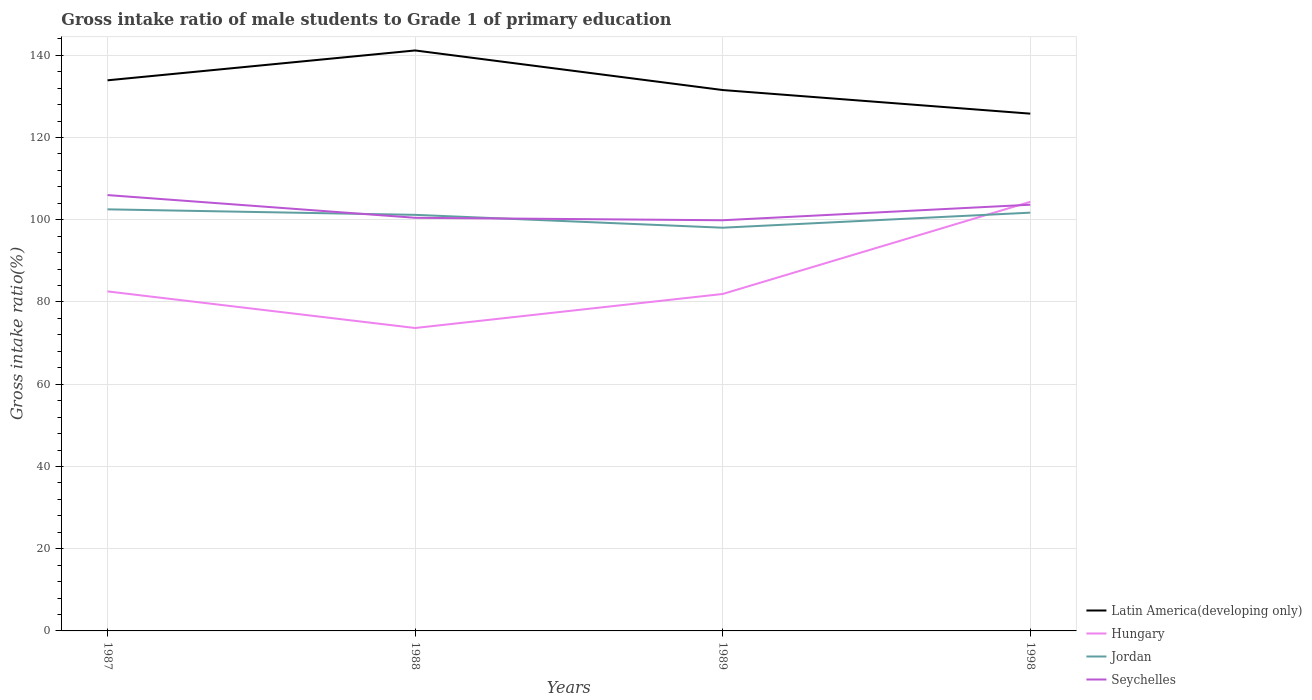How many different coloured lines are there?
Offer a terse response. 4. Does the line corresponding to Seychelles intersect with the line corresponding to Hungary?
Give a very brief answer. Yes. Across all years, what is the maximum gross intake ratio in Seychelles?
Your answer should be very brief. 99.88. In which year was the gross intake ratio in Seychelles maximum?
Your answer should be very brief. 1989. What is the total gross intake ratio in Jordan in the graph?
Offer a terse response. 4.46. What is the difference between the highest and the second highest gross intake ratio in Jordan?
Make the answer very short. 4.46. Is the gross intake ratio in Hungary strictly greater than the gross intake ratio in Jordan over the years?
Ensure brevity in your answer.  No. How many lines are there?
Keep it short and to the point. 4. Are the values on the major ticks of Y-axis written in scientific E-notation?
Give a very brief answer. No. Does the graph contain grids?
Your response must be concise. Yes. Where does the legend appear in the graph?
Give a very brief answer. Bottom right. How many legend labels are there?
Your answer should be compact. 4. How are the legend labels stacked?
Offer a terse response. Vertical. What is the title of the graph?
Offer a very short reply. Gross intake ratio of male students to Grade 1 of primary education. Does "Honduras" appear as one of the legend labels in the graph?
Make the answer very short. No. What is the label or title of the X-axis?
Provide a short and direct response. Years. What is the label or title of the Y-axis?
Ensure brevity in your answer.  Gross intake ratio(%). What is the Gross intake ratio(%) of Latin America(developing only) in 1987?
Your response must be concise. 133.92. What is the Gross intake ratio(%) in Hungary in 1987?
Provide a short and direct response. 82.57. What is the Gross intake ratio(%) of Jordan in 1987?
Ensure brevity in your answer.  102.53. What is the Gross intake ratio(%) in Seychelles in 1987?
Ensure brevity in your answer.  106. What is the Gross intake ratio(%) in Latin America(developing only) in 1988?
Provide a succinct answer. 141.18. What is the Gross intake ratio(%) of Hungary in 1988?
Give a very brief answer. 73.68. What is the Gross intake ratio(%) in Jordan in 1988?
Offer a terse response. 101.2. What is the Gross intake ratio(%) in Seychelles in 1988?
Ensure brevity in your answer.  100.48. What is the Gross intake ratio(%) in Latin America(developing only) in 1989?
Ensure brevity in your answer.  131.55. What is the Gross intake ratio(%) in Hungary in 1989?
Offer a very short reply. 81.95. What is the Gross intake ratio(%) in Jordan in 1989?
Provide a succinct answer. 98.07. What is the Gross intake ratio(%) in Seychelles in 1989?
Ensure brevity in your answer.  99.88. What is the Gross intake ratio(%) of Latin America(developing only) in 1998?
Provide a short and direct response. 125.81. What is the Gross intake ratio(%) in Hungary in 1998?
Keep it short and to the point. 104.37. What is the Gross intake ratio(%) of Jordan in 1998?
Your response must be concise. 101.73. What is the Gross intake ratio(%) in Seychelles in 1998?
Give a very brief answer. 103.66. Across all years, what is the maximum Gross intake ratio(%) in Latin America(developing only)?
Offer a very short reply. 141.18. Across all years, what is the maximum Gross intake ratio(%) in Hungary?
Your response must be concise. 104.37. Across all years, what is the maximum Gross intake ratio(%) of Jordan?
Your answer should be compact. 102.53. Across all years, what is the maximum Gross intake ratio(%) in Seychelles?
Provide a succinct answer. 106. Across all years, what is the minimum Gross intake ratio(%) in Latin America(developing only)?
Provide a succinct answer. 125.81. Across all years, what is the minimum Gross intake ratio(%) of Hungary?
Offer a very short reply. 73.68. Across all years, what is the minimum Gross intake ratio(%) in Jordan?
Offer a very short reply. 98.07. Across all years, what is the minimum Gross intake ratio(%) in Seychelles?
Your response must be concise. 99.88. What is the total Gross intake ratio(%) in Latin America(developing only) in the graph?
Make the answer very short. 532.46. What is the total Gross intake ratio(%) of Hungary in the graph?
Your response must be concise. 342.57. What is the total Gross intake ratio(%) in Jordan in the graph?
Your answer should be very brief. 403.53. What is the total Gross intake ratio(%) of Seychelles in the graph?
Offer a very short reply. 410.03. What is the difference between the Gross intake ratio(%) in Latin America(developing only) in 1987 and that in 1988?
Your response must be concise. -7.26. What is the difference between the Gross intake ratio(%) of Hungary in 1987 and that in 1988?
Provide a short and direct response. 8.9. What is the difference between the Gross intake ratio(%) of Jordan in 1987 and that in 1988?
Provide a succinct answer. 1.34. What is the difference between the Gross intake ratio(%) in Seychelles in 1987 and that in 1988?
Provide a succinct answer. 5.52. What is the difference between the Gross intake ratio(%) of Latin America(developing only) in 1987 and that in 1989?
Offer a very short reply. 2.37. What is the difference between the Gross intake ratio(%) of Hungary in 1987 and that in 1989?
Provide a succinct answer. 0.62. What is the difference between the Gross intake ratio(%) of Jordan in 1987 and that in 1989?
Your answer should be compact. 4.46. What is the difference between the Gross intake ratio(%) of Seychelles in 1987 and that in 1989?
Your answer should be very brief. 6.12. What is the difference between the Gross intake ratio(%) of Latin America(developing only) in 1987 and that in 1998?
Ensure brevity in your answer.  8.11. What is the difference between the Gross intake ratio(%) of Hungary in 1987 and that in 1998?
Keep it short and to the point. -21.8. What is the difference between the Gross intake ratio(%) of Jordan in 1987 and that in 1998?
Give a very brief answer. 0.8. What is the difference between the Gross intake ratio(%) of Seychelles in 1987 and that in 1998?
Make the answer very short. 2.34. What is the difference between the Gross intake ratio(%) in Latin America(developing only) in 1988 and that in 1989?
Your response must be concise. 9.63. What is the difference between the Gross intake ratio(%) in Hungary in 1988 and that in 1989?
Offer a terse response. -8.27. What is the difference between the Gross intake ratio(%) in Jordan in 1988 and that in 1989?
Offer a terse response. 3.13. What is the difference between the Gross intake ratio(%) in Seychelles in 1988 and that in 1989?
Give a very brief answer. 0.6. What is the difference between the Gross intake ratio(%) of Latin America(developing only) in 1988 and that in 1998?
Provide a short and direct response. 15.37. What is the difference between the Gross intake ratio(%) in Hungary in 1988 and that in 1998?
Your response must be concise. -30.69. What is the difference between the Gross intake ratio(%) of Jordan in 1988 and that in 1998?
Provide a succinct answer. -0.53. What is the difference between the Gross intake ratio(%) of Seychelles in 1988 and that in 1998?
Offer a terse response. -3.18. What is the difference between the Gross intake ratio(%) in Latin America(developing only) in 1989 and that in 1998?
Give a very brief answer. 5.74. What is the difference between the Gross intake ratio(%) of Hungary in 1989 and that in 1998?
Your answer should be very brief. -22.42. What is the difference between the Gross intake ratio(%) in Jordan in 1989 and that in 1998?
Offer a terse response. -3.66. What is the difference between the Gross intake ratio(%) in Seychelles in 1989 and that in 1998?
Your answer should be compact. -3.78. What is the difference between the Gross intake ratio(%) of Latin America(developing only) in 1987 and the Gross intake ratio(%) of Hungary in 1988?
Your answer should be very brief. 60.24. What is the difference between the Gross intake ratio(%) in Latin America(developing only) in 1987 and the Gross intake ratio(%) in Jordan in 1988?
Make the answer very short. 32.72. What is the difference between the Gross intake ratio(%) of Latin America(developing only) in 1987 and the Gross intake ratio(%) of Seychelles in 1988?
Your answer should be very brief. 33.44. What is the difference between the Gross intake ratio(%) of Hungary in 1987 and the Gross intake ratio(%) of Jordan in 1988?
Give a very brief answer. -18.62. What is the difference between the Gross intake ratio(%) in Hungary in 1987 and the Gross intake ratio(%) in Seychelles in 1988?
Ensure brevity in your answer.  -17.91. What is the difference between the Gross intake ratio(%) in Jordan in 1987 and the Gross intake ratio(%) in Seychelles in 1988?
Offer a very short reply. 2.05. What is the difference between the Gross intake ratio(%) in Latin America(developing only) in 1987 and the Gross intake ratio(%) in Hungary in 1989?
Make the answer very short. 51.97. What is the difference between the Gross intake ratio(%) of Latin America(developing only) in 1987 and the Gross intake ratio(%) of Jordan in 1989?
Provide a short and direct response. 35.85. What is the difference between the Gross intake ratio(%) in Latin America(developing only) in 1987 and the Gross intake ratio(%) in Seychelles in 1989?
Provide a succinct answer. 34.03. What is the difference between the Gross intake ratio(%) in Hungary in 1987 and the Gross intake ratio(%) in Jordan in 1989?
Your response must be concise. -15.5. What is the difference between the Gross intake ratio(%) of Hungary in 1987 and the Gross intake ratio(%) of Seychelles in 1989?
Offer a very short reply. -17.31. What is the difference between the Gross intake ratio(%) of Jordan in 1987 and the Gross intake ratio(%) of Seychelles in 1989?
Give a very brief answer. 2.65. What is the difference between the Gross intake ratio(%) in Latin America(developing only) in 1987 and the Gross intake ratio(%) in Hungary in 1998?
Offer a terse response. 29.55. What is the difference between the Gross intake ratio(%) in Latin America(developing only) in 1987 and the Gross intake ratio(%) in Jordan in 1998?
Provide a short and direct response. 32.19. What is the difference between the Gross intake ratio(%) of Latin America(developing only) in 1987 and the Gross intake ratio(%) of Seychelles in 1998?
Offer a very short reply. 30.26. What is the difference between the Gross intake ratio(%) of Hungary in 1987 and the Gross intake ratio(%) of Jordan in 1998?
Provide a short and direct response. -19.16. What is the difference between the Gross intake ratio(%) in Hungary in 1987 and the Gross intake ratio(%) in Seychelles in 1998?
Make the answer very short. -21.09. What is the difference between the Gross intake ratio(%) of Jordan in 1987 and the Gross intake ratio(%) of Seychelles in 1998?
Give a very brief answer. -1.13. What is the difference between the Gross intake ratio(%) in Latin America(developing only) in 1988 and the Gross intake ratio(%) in Hungary in 1989?
Offer a terse response. 59.23. What is the difference between the Gross intake ratio(%) of Latin America(developing only) in 1988 and the Gross intake ratio(%) of Jordan in 1989?
Keep it short and to the point. 43.11. What is the difference between the Gross intake ratio(%) in Latin America(developing only) in 1988 and the Gross intake ratio(%) in Seychelles in 1989?
Your response must be concise. 41.3. What is the difference between the Gross intake ratio(%) in Hungary in 1988 and the Gross intake ratio(%) in Jordan in 1989?
Offer a very short reply. -24.39. What is the difference between the Gross intake ratio(%) of Hungary in 1988 and the Gross intake ratio(%) of Seychelles in 1989?
Your answer should be very brief. -26.21. What is the difference between the Gross intake ratio(%) in Jordan in 1988 and the Gross intake ratio(%) in Seychelles in 1989?
Your answer should be very brief. 1.31. What is the difference between the Gross intake ratio(%) in Latin America(developing only) in 1988 and the Gross intake ratio(%) in Hungary in 1998?
Ensure brevity in your answer.  36.81. What is the difference between the Gross intake ratio(%) in Latin America(developing only) in 1988 and the Gross intake ratio(%) in Jordan in 1998?
Make the answer very short. 39.45. What is the difference between the Gross intake ratio(%) of Latin America(developing only) in 1988 and the Gross intake ratio(%) of Seychelles in 1998?
Your answer should be very brief. 37.52. What is the difference between the Gross intake ratio(%) of Hungary in 1988 and the Gross intake ratio(%) of Jordan in 1998?
Your answer should be very brief. -28.05. What is the difference between the Gross intake ratio(%) of Hungary in 1988 and the Gross intake ratio(%) of Seychelles in 1998?
Your response must be concise. -29.99. What is the difference between the Gross intake ratio(%) of Jordan in 1988 and the Gross intake ratio(%) of Seychelles in 1998?
Your answer should be very brief. -2.46. What is the difference between the Gross intake ratio(%) in Latin America(developing only) in 1989 and the Gross intake ratio(%) in Hungary in 1998?
Provide a succinct answer. 27.18. What is the difference between the Gross intake ratio(%) in Latin America(developing only) in 1989 and the Gross intake ratio(%) in Jordan in 1998?
Provide a succinct answer. 29.82. What is the difference between the Gross intake ratio(%) of Latin America(developing only) in 1989 and the Gross intake ratio(%) of Seychelles in 1998?
Offer a terse response. 27.89. What is the difference between the Gross intake ratio(%) in Hungary in 1989 and the Gross intake ratio(%) in Jordan in 1998?
Your answer should be very brief. -19.78. What is the difference between the Gross intake ratio(%) of Hungary in 1989 and the Gross intake ratio(%) of Seychelles in 1998?
Keep it short and to the point. -21.71. What is the difference between the Gross intake ratio(%) in Jordan in 1989 and the Gross intake ratio(%) in Seychelles in 1998?
Keep it short and to the point. -5.59. What is the average Gross intake ratio(%) in Latin America(developing only) per year?
Keep it short and to the point. 133.12. What is the average Gross intake ratio(%) in Hungary per year?
Make the answer very short. 85.64. What is the average Gross intake ratio(%) in Jordan per year?
Give a very brief answer. 100.88. What is the average Gross intake ratio(%) in Seychelles per year?
Provide a succinct answer. 102.51. In the year 1987, what is the difference between the Gross intake ratio(%) of Latin America(developing only) and Gross intake ratio(%) of Hungary?
Give a very brief answer. 51.34. In the year 1987, what is the difference between the Gross intake ratio(%) of Latin America(developing only) and Gross intake ratio(%) of Jordan?
Offer a very short reply. 31.38. In the year 1987, what is the difference between the Gross intake ratio(%) in Latin America(developing only) and Gross intake ratio(%) in Seychelles?
Provide a succinct answer. 27.91. In the year 1987, what is the difference between the Gross intake ratio(%) in Hungary and Gross intake ratio(%) in Jordan?
Provide a short and direct response. -19.96. In the year 1987, what is the difference between the Gross intake ratio(%) of Hungary and Gross intake ratio(%) of Seychelles?
Provide a short and direct response. -23.43. In the year 1987, what is the difference between the Gross intake ratio(%) of Jordan and Gross intake ratio(%) of Seychelles?
Give a very brief answer. -3.47. In the year 1988, what is the difference between the Gross intake ratio(%) in Latin America(developing only) and Gross intake ratio(%) in Hungary?
Provide a succinct answer. 67.5. In the year 1988, what is the difference between the Gross intake ratio(%) in Latin America(developing only) and Gross intake ratio(%) in Jordan?
Offer a very short reply. 39.98. In the year 1988, what is the difference between the Gross intake ratio(%) of Latin America(developing only) and Gross intake ratio(%) of Seychelles?
Your answer should be compact. 40.7. In the year 1988, what is the difference between the Gross intake ratio(%) of Hungary and Gross intake ratio(%) of Jordan?
Offer a terse response. -27.52. In the year 1988, what is the difference between the Gross intake ratio(%) in Hungary and Gross intake ratio(%) in Seychelles?
Your response must be concise. -26.81. In the year 1988, what is the difference between the Gross intake ratio(%) of Jordan and Gross intake ratio(%) of Seychelles?
Keep it short and to the point. 0.72. In the year 1989, what is the difference between the Gross intake ratio(%) of Latin America(developing only) and Gross intake ratio(%) of Hungary?
Your answer should be compact. 49.6. In the year 1989, what is the difference between the Gross intake ratio(%) in Latin America(developing only) and Gross intake ratio(%) in Jordan?
Ensure brevity in your answer.  33.48. In the year 1989, what is the difference between the Gross intake ratio(%) in Latin America(developing only) and Gross intake ratio(%) in Seychelles?
Make the answer very short. 31.67. In the year 1989, what is the difference between the Gross intake ratio(%) in Hungary and Gross intake ratio(%) in Jordan?
Make the answer very short. -16.12. In the year 1989, what is the difference between the Gross intake ratio(%) in Hungary and Gross intake ratio(%) in Seychelles?
Your response must be concise. -17.93. In the year 1989, what is the difference between the Gross intake ratio(%) in Jordan and Gross intake ratio(%) in Seychelles?
Keep it short and to the point. -1.81. In the year 1998, what is the difference between the Gross intake ratio(%) of Latin America(developing only) and Gross intake ratio(%) of Hungary?
Offer a terse response. 21.44. In the year 1998, what is the difference between the Gross intake ratio(%) of Latin America(developing only) and Gross intake ratio(%) of Jordan?
Provide a short and direct response. 24.08. In the year 1998, what is the difference between the Gross intake ratio(%) in Latin America(developing only) and Gross intake ratio(%) in Seychelles?
Keep it short and to the point. 22.15. In the year 1998, what is the difference between the Gross intake ratio(%) in Hungary and Gross intake ratio(%) in Jordan?
Offer a terse response. 2.64. In the year 1998, what is the difference between the Gross intake ratio(%) in Hungary and Gross intake ratio(%) in Seychelles?
Keep it short and to the point. 0.71. In the year 1998, what is the difference between the Gross intake ratio(%) in Jordan and Gross intake ratio(%) in Seychelles?
Offer a terse response. -1.93. What is the ratio of the Gross intake ratio(%) in Latin America(developing only) in 1987 to that in 1988?
Keep it short and to the point. 0.95. What is the ratio of the Gross intake ratio(%) of Hungary in 1987 to that in 1988?
Ensure brevity in your answer.  1.12. What is the ratio of the Gross intake ratio(%) in Jordan in 1987 to that in 1988?
Provide a short and direct response. 1.01. What is the ratio of the Gross intake ratio(%) of Seychelles in 1987 to that in 1988?
Your answer should be compact. 1.05. What is the ratio of the Gross intake ratio(%) in Hungary in 1987 to that in 1989?
Provide a succinct answer. 1.01. What is the ratio of the Gross intake ratio(%) of Jordan in 1987 to that in 1989?
Offer a very short reply. 1.05. What is the ratio of the Gross intake ratio(%) in Seychelles in 1987 to that in 1989?
Keep it short and to the point. 1.06. What is the ratio of the Gross intake ratio(%) of Latin America(developing only) in 1987 to that in 1998?
Offer a very short reply. 1.06. What is the ratio of the Gross intake ratio(%) of Hungary in 1987 to that in 1998?
Offer a very short reply. 0.79. What is the ratio of the Gross intake ratio(%) in Jordan in 1987 to that in 1998?
Your response must be concise. 1.01. What is the ratio of the Gross intake ratio(%) of Seychelles in 1987 to that in 1998?
Provide a succinct answer. 1.02. What is the ratio of the Gross intake ratio(%) of Latin America(developing only) in 1988 to that in 1989?
Offer a terse response. 1.07. What is the ratio of the Gross intake ratio(%) in Hungary in 1988 to that in 1989?
Your response must be concise. 0.9. What is the ratio of the Gross intake ratio(%) in Jordan in 1988 to that in 1989?
Provide a short and direct response. 1.03. What is the ratio of the Gross intake ratio(%) of Latin America(developing only) in 1988 to that in 1998?
Keep it short and to the point. 1.12. What is the ratio of the Gross intake ratio(%) in Hungary in 1988 to that in 1998?
Your answer should be compact. 0.71. What is the ratio of the Gross intake ratio(%) of Seychelles in 1988 to that in 1998?
Provide a short and direct response. 0.97. What is the ratio of the Gross intake ratio(%) in Latin America(developing only) in 1989 to that in 1998?
Your answer should be very brief. 1.05. What is the ratio of the Gross intake ratio(%) of Hungary in 1989 to that in 1998?
Give a very brief answer. 0.79. What is the ratio of the Gross intake ratio(%) in Seychelles in 1989 to that in 1998?
Ensure brevity in your answer.  0.96. What is the difference between the highest and the second highest Gross intake ratio(%) of Latin America(developing only)?
Give a very brief answer. 7.26. What is the difference between the highest and the second highest Gross intake ratio(%) of Hungary?
Give a very brief answer. 21.8. What is the difference between the highest and the second highest Gross intake ratio(%) in Jordan?
Your answer should be very brief. 0.8. What is the difference between the highest and the second highest Gross intake ratio(%) in Seychelles?
Offer a very short reply. 2.34. What is the difference between the highest and the lowest Gross intake ratio(%) of Latin America(developing only)?
Provide a short and direct response. 15.37. What is the difference between the highest and the lowest Gross intake ratio(%) in Hungary?
Ensure brevity in your answer.  30.69. What is the difference between the highest and the lowest Gross intake ratio(%) in Jordan?
Make the answer very short. 4.46. What is the difference between the highest and the lowest Gross intake ratio(%) in Seychelles?
Give a very brief answer. 6.12. 